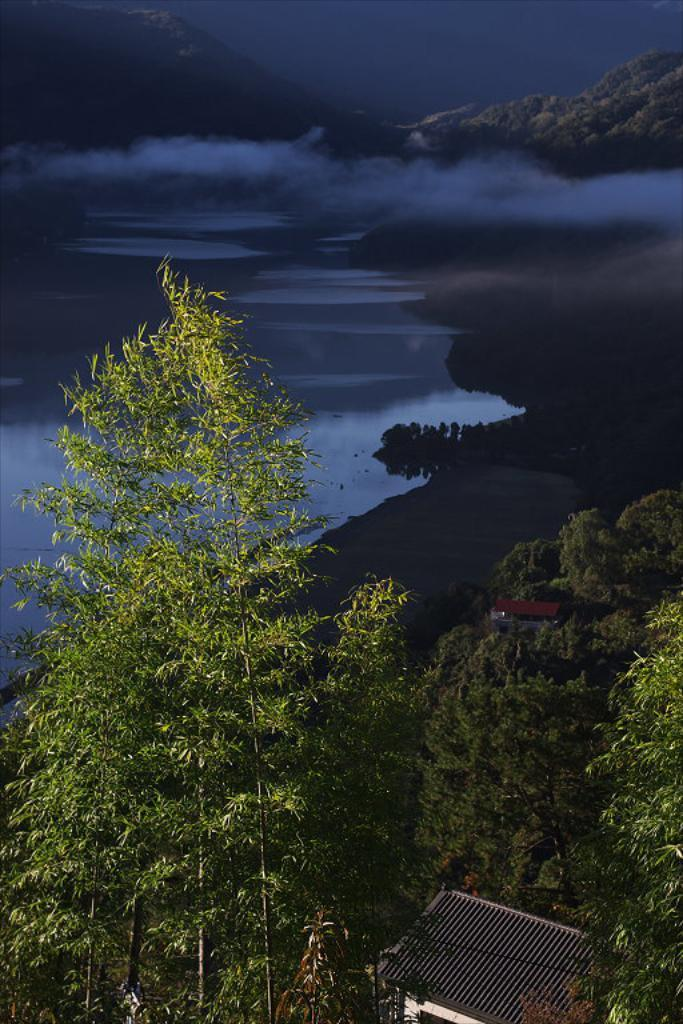What type of vegetation is present in the image? There are green plants in the image. What body of water can be seen in the image? There is a lake with water in the image. What color is the sky in the image? The sky is blue in the image. Are there any weather phenomena visible in the image? Clouds are visible in the image. What type of brass instrument is being played near the lake in the image? There is no brass instrument or person playing an instrument present in the image. Is there a volcano visible in the image? No, there is no volcano present in the image. 